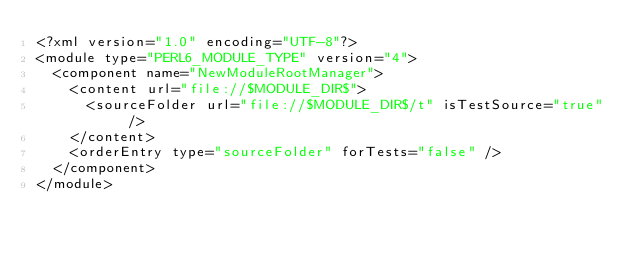Convert code to text. <code><loc_0><loc_0><loc_500><loc_500><_XML_><?xml version="1.0" encoding="UTF-8"?>
<module type="PERL6_MODULE_TYPE" version="4">
  <component name="NewModuleRootManager">
    <content url="file://$MODULE_DIR$">
      <sourceFolder url="file://$MODULE_DIR$/t" isTestSource="true" />
    </content>
    <orderEntry type="sourceFolder" forTests="false" />
  </component>
</module></code> 